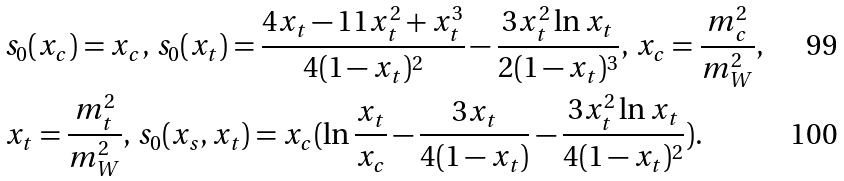<formula> <loc_0><loc_0><loc_500><loc_500>& s _ { 0 } ( x _ { c } ) = x _ { c } , \, s _ { 0 } ( x _ { t } ) = \frac { 4 x _ { t } - 1 1 x ^ { 2 } _ { t } + x ^ { 3 } _ { t } } { 4 ( 1 - x _ { t } ) ^ { 2 } } - \frac { 3 x ^ { 2 } _ { t } \ln { x _ { t } } } { 2 ( 1 - x _ { t } ) ^ { 3 } } , \, x _ { c } = \frac { m ^ { 2 } _ { c } } { m ^ { 2 } _ { W } } , \, \\ & x _ { t } = \frac { m ^ { 2 } _ { t } } { m ^ { 2 } _ { W } } , \, s _ { 0 } ( x _ { s } , x _ { t } ) = x _ { c } ( \ln { \frac { x _ { t } } { x _ { c } } } - \frac { 3 x _ { t } } { 4 ( 1 - x _ { t } ) } - \frac { 3 x ^ { 2 } _ { t } \ln { x _ { t } } } { 4 ( 1 - x _ { t } ) ^ { 2 } } ) .</formula> 